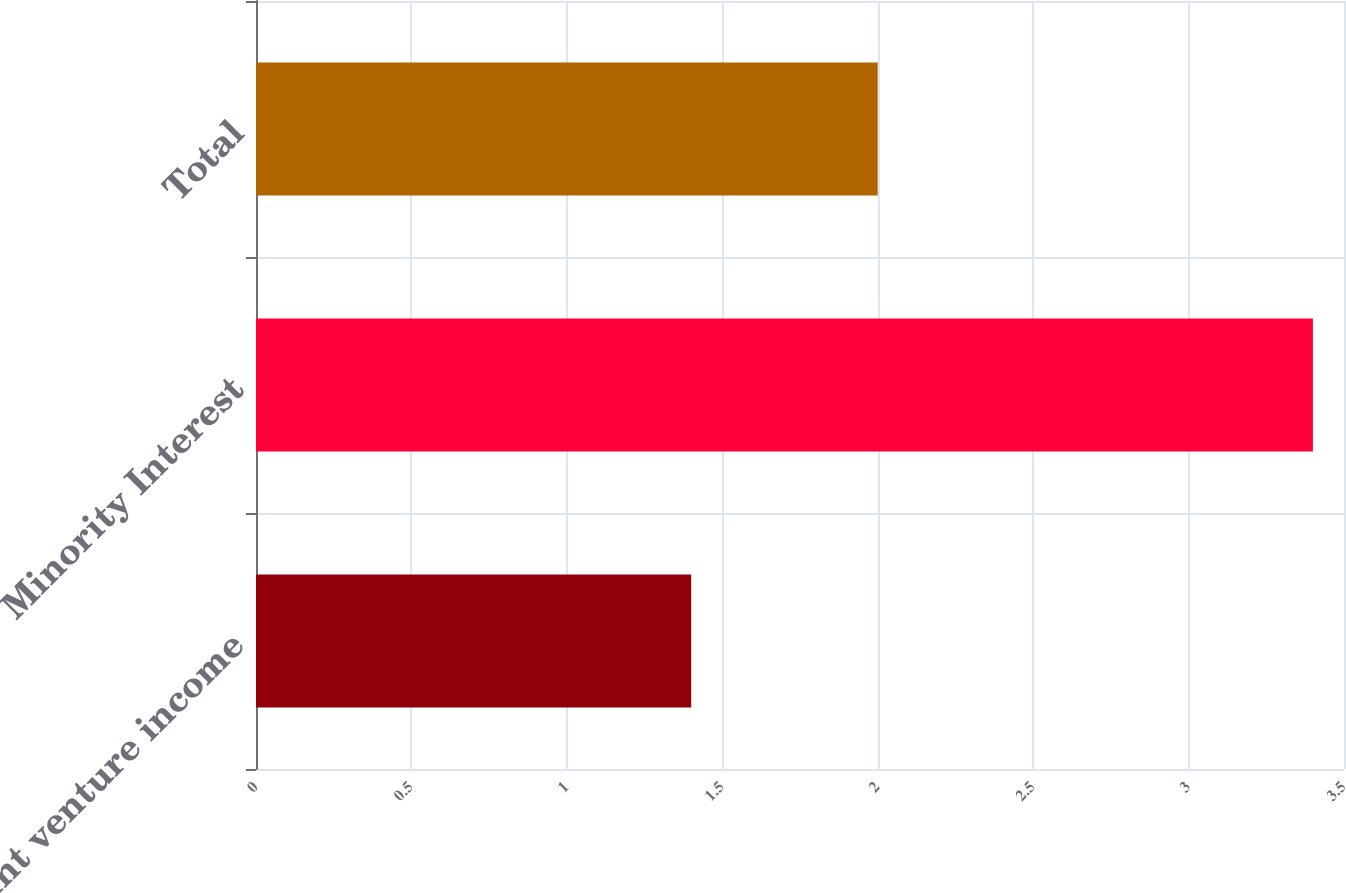Convert chart to OTSL. <chart><loc_0><loc_0><loc_500><loc_500><bar_chart><fcel>Joint venture income<fcel>Minority Interest<fcel>Total<nl><fcel>1.4<fcel>3.4<fcel>2<nl></chart> 